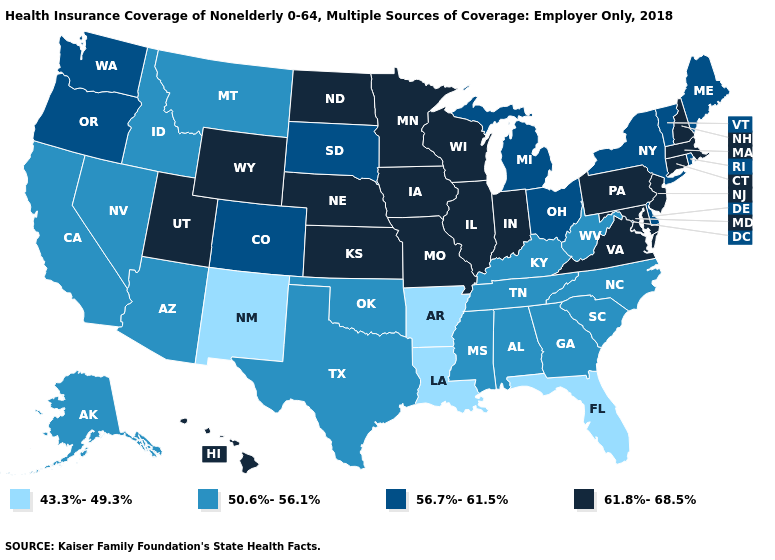Does the first symbol in the legend represent the smallest category?
Quick response, please. Yes. Does Iowa have the lowest value in the MidWest?
Short answer required. No. How many symbols are there in the legend?
Quick response, please. 4. Name the states that have a value in the range 43.3%-49.3%?
Keep it brief. Arkansas, Florida, Louisiana, New Mexico. Does Utah have the highest value in the West?
Keep it brief. Yes. Name the states that have a value in the range 56.7%-61.5%?
Concise answer only. Colorado, Delaware, Maine, Michigan, New York, Ohio, Oregon, Rhode Island, South Dakota, Vermont, Washington. Among the states that border Iowa , does South Dakota have the lowest value?
Be succinct. Yes. Among the states that border Washington , does Idaho have the highest value?
Be succinct. No. What is the value of Michigan?
Keep it brief. 56.7%-61.5%. What is the value of Oklahoma?
Quick response, please. 50.6%-56.1%. Does South Carolina have the highest value in the South?
Quick response, please. No. What is the value of Florida?
Concise answer only. 43.3%-49.3%. Name the states that have a value in the range 43.3%-49.3%?
Be succinct. Arkansas, Florida, Louisiana, New Mexico. Among the states that border Missouri , which have the lowest value?
Answer briefly. Arkansas. Does Wyoming have the highest value in the West?
Short answer required. Yes. 